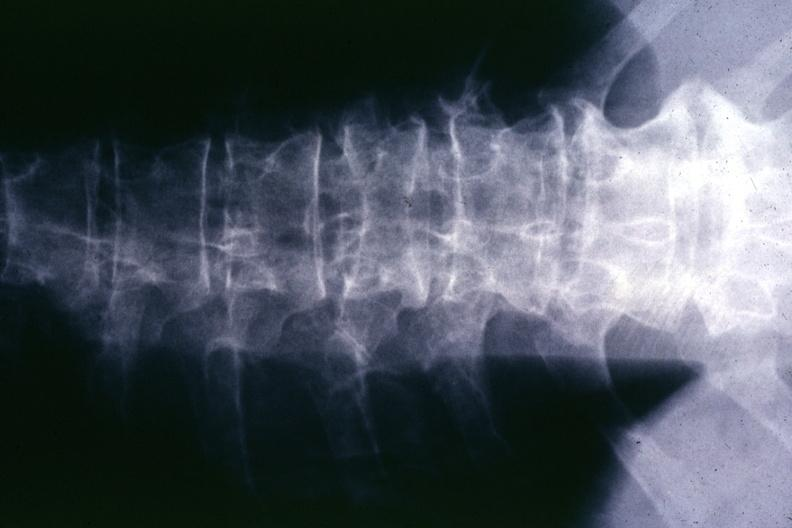what is present?
Answer the question using a single word or phrase. Joints 